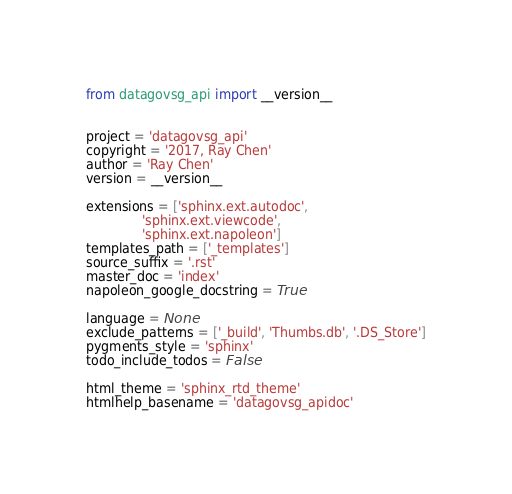<code> <loc_0><loc_0><loc_500><loc_500><_Python_>
from datagovsg_api import __version__


project = 'datagovsg_api'
copyright = '2017, Ray Chen'
author = 'Ray Chen'
version = __version__

extensions = ['sphinx.ext.autodoc',
              'sphinx.ext.viewcode',
              'sphinx.ext.napoleon']
templates_path = ['_templates']
source_suffix = '.rst'
master_doc = 'index'
napoleon_google_docstring = True

language = None
exclude_patterns = ['_build', 'Thumbs.db', '.DS_Store']
pygments_style = 'sphinx'
todo_include_todos = False

html_theme = 'sphinx_rtd_theme'
htmlhelp_basename = 'datagovsg_apidoc'
</code> 